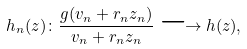Convert formula to latex. <formula><loc_0><loc_0><loc_500><loc_500>h _ { n } ( z ) \colon \frac { g ( v _ { n } + r _ { n } z _ { n } ) } { v _ { n } + r _ { n } z _ { n } } \longrightarrow h ( z ) , \label l e { p a s d e p o l e s 1 }</formula> 